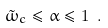Convert formula to latex. <formula><loc_0><loc_0><loc_500><loc_500>\tilde { \omega } _ { c } \leq \alpha \leq 1 \ .</formula> 